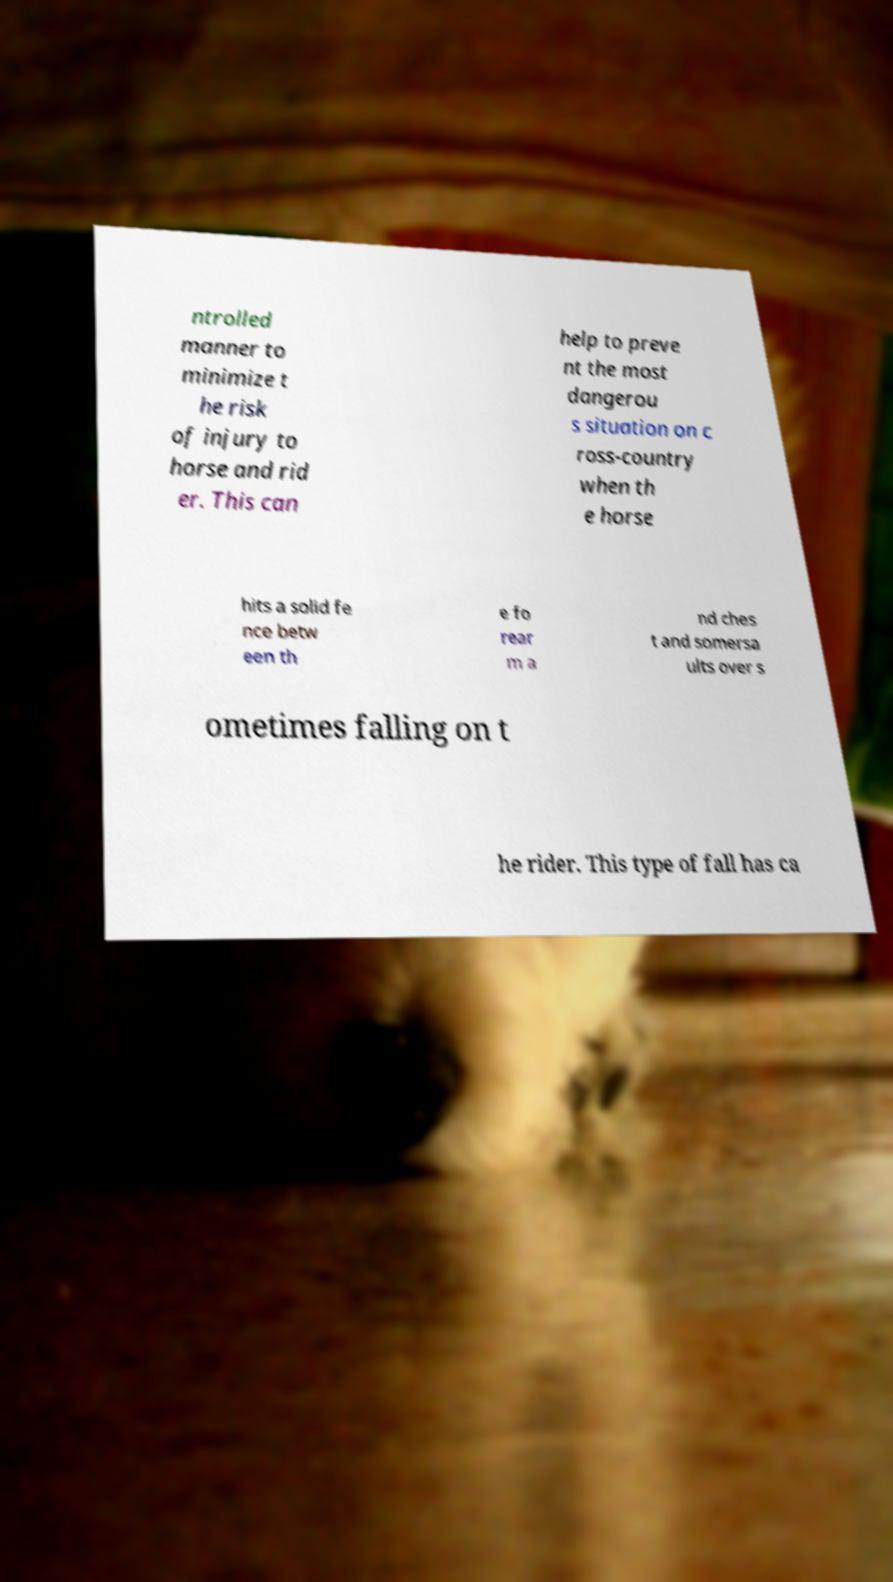There's text embedded in this image that I need extracted. Can you transcribe it verbatim? ntrolled manner to minimize t he risk of injury to horse and rid er. This can help to preve nt the most dangerou s situation on c ross-country when th e horse hits a solid fe nce betw een th e fo rear m a nd ches t and somersa ults over s ometimes falling on t he rider. This type of fall has ca 